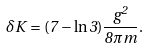<formula> <loc_0><loc_0><loc_500><loc_500>\delta K = ( 7 - \ln 3 ) \frac { g ^ { 2 } } { 8 \pi m } .</formula> 